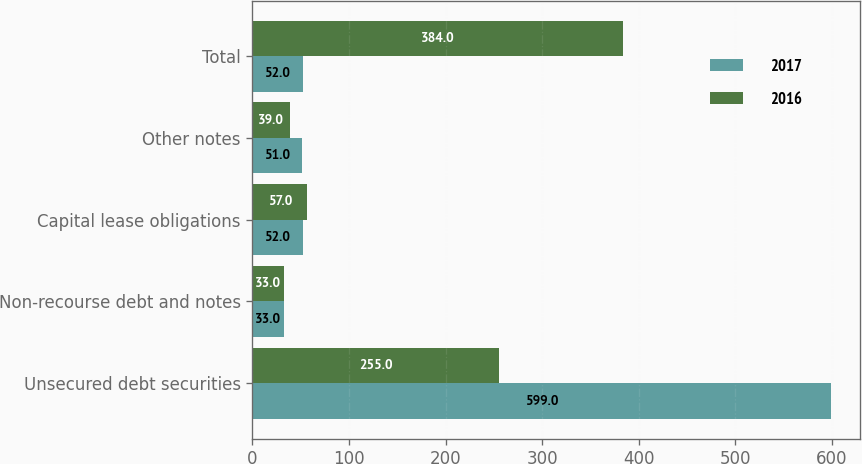<chart> <loc_0><loc_0><loc_500><loc_500><stacked_bar_chart><ecel><fcel>Unsecured debt securities<fcel>Non-recourse debt and notes<fcel>Capital lease obligations<fcel>Other notes<fcel>Total<nl><fcel>2017<fcel>599<fcel>33<fcel>52<fcel>51<fcel>52<nl><fcel>2016<fcel>255<fcel>33<fcel>57<fcel>39<fcel>384<nl></chart> 